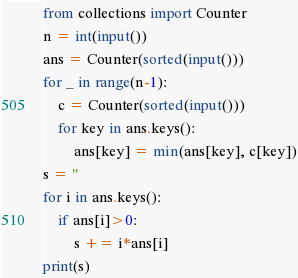<code> <loc_0><loc_0><loc_500><loc_500><_Python_>from collections import Counter
n = int(input())
ans = Counter(sorted(input()))
for _ in range(n-1):
    c = Counter(sorted(input()))
    for key in ans.keys():
        ans[key] = min(ans[key], c[key])
s = ''
for i in ans.keys():
    if ans[i]>0:
        s += i*ans[i]
print(s)
</code> 